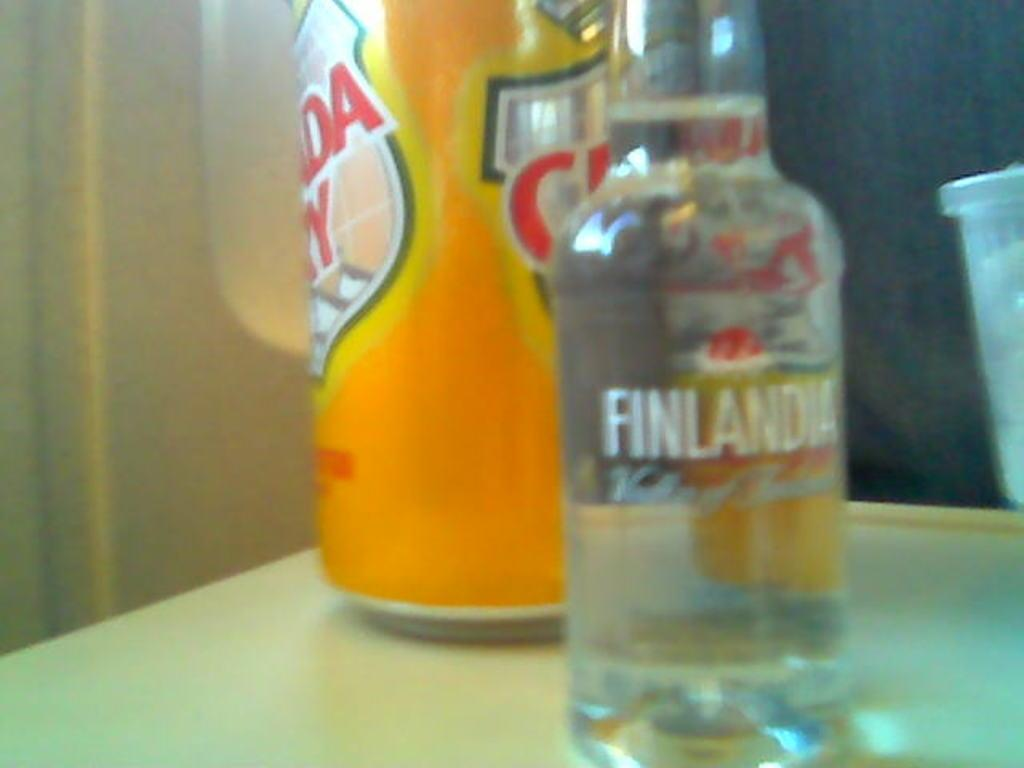<image>
Summarize the visual content of the image. A bottle of Finlandia sits on a table next to a can of Canada Dry. 